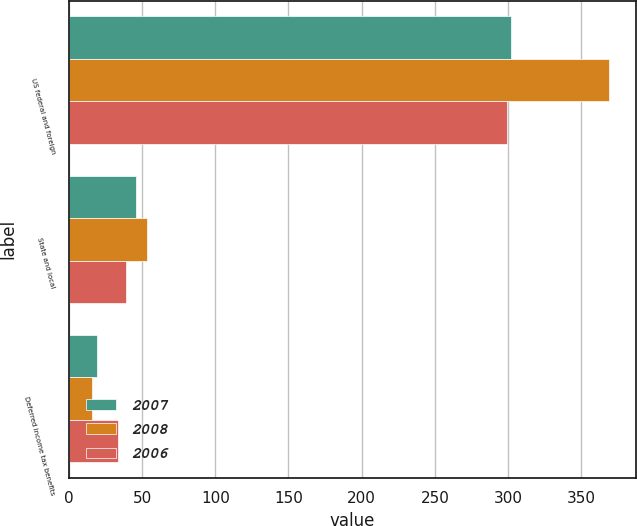Convert chart. <chart><loc_0><loc_0><loc_500><loc_500><stacked_bar_chart><ecel><fcel>US federal and foreign<fcel>State and local<fcel>Deferred income tax benefits<nl><fcel>2007<fcel>301.9<fcel>45.8<fcel>19<nl><fcel>2008<fcel>368.6<fcel>53.3<fcel>15.7<nl><fcel>2006<fcel>299.5<fcel>39.3<fcel>33.4<nl></chart> 